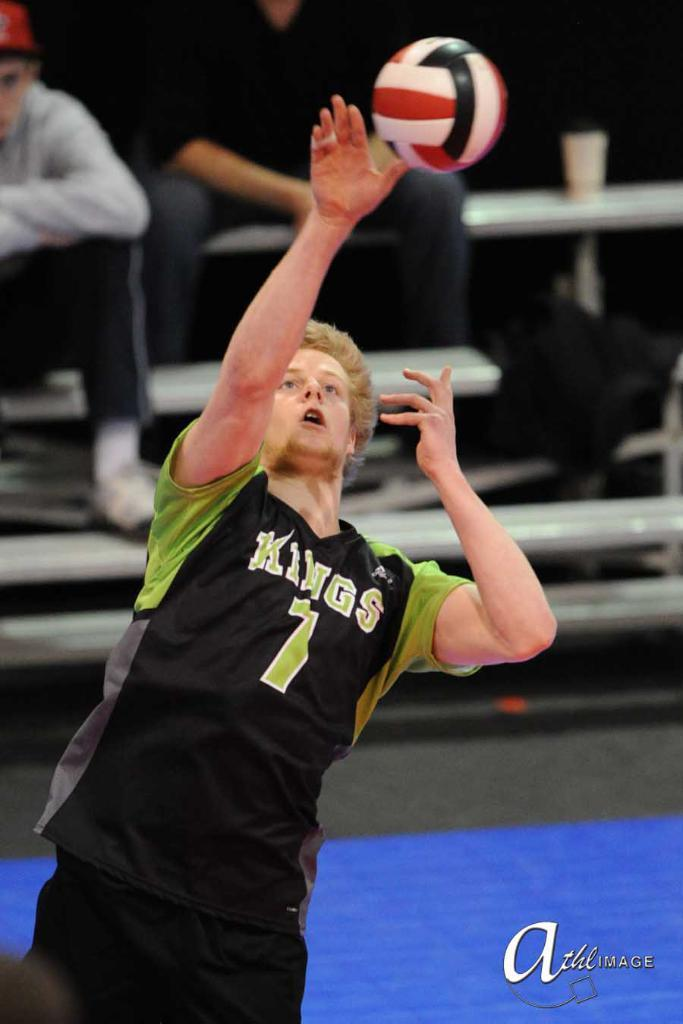What is the man in the image doing? The man is playing volleyball in the image. Are there any spectators in the image? Yes, there are people seated and watching the game. What type of stick is the man using to play volleyball in the image? There is no stick present in the image; the man is playing volleyball using his hands and a ball. 